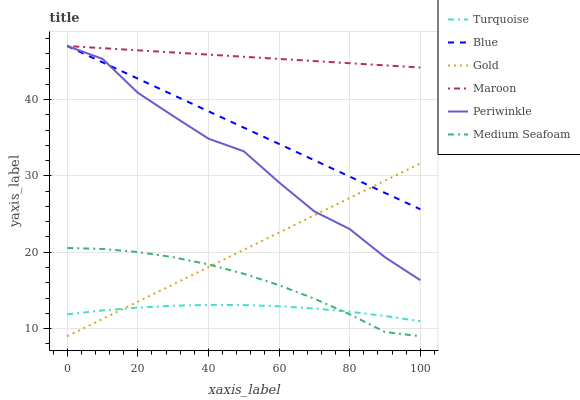Does Turquoise have the minimum area under the curve?
Answer yes or no. Yes. Does Maroon have the maximum area under the curve?
Answer yes or no. Yes. Does Gold have the minimum area under the curve?
Answer yes or no. No. Does Gold have the maximum area under the curve?
Answer yes or no. No. Is Blue the smoothest?
Answer yes or no. Yes. Is Periwinkle the roughest?
Answer yes or no. Yes. Is Turquoise the smoothest?
Answer yes or no. No. Is Turquoise the roughest?
Answer yes or no. No. Does Gold have the lowest value?
Answer yes or no. Yes. Does Turquoise have the lowest value?
Answer yes or no. No. Does Periwinkle have the highest value?
Answer yes or no. Yes. Does Gold have the highest value?
Answer yes or no. No. Is Medium Seafoam less than Blue?
Answer yes or no. Yes. Is Blue greater than Medium Seafoam?
Answer yes or no. Yes. Does Gold intersect Blue?
Answer yes or no. Yes. Is Gold less than Blue?
Answer yes or no. No. Is Gold greater than Blue?
Answer yes or no. No. Does Medium Seafoam intersect Blue?
Answer yes or no. No. 